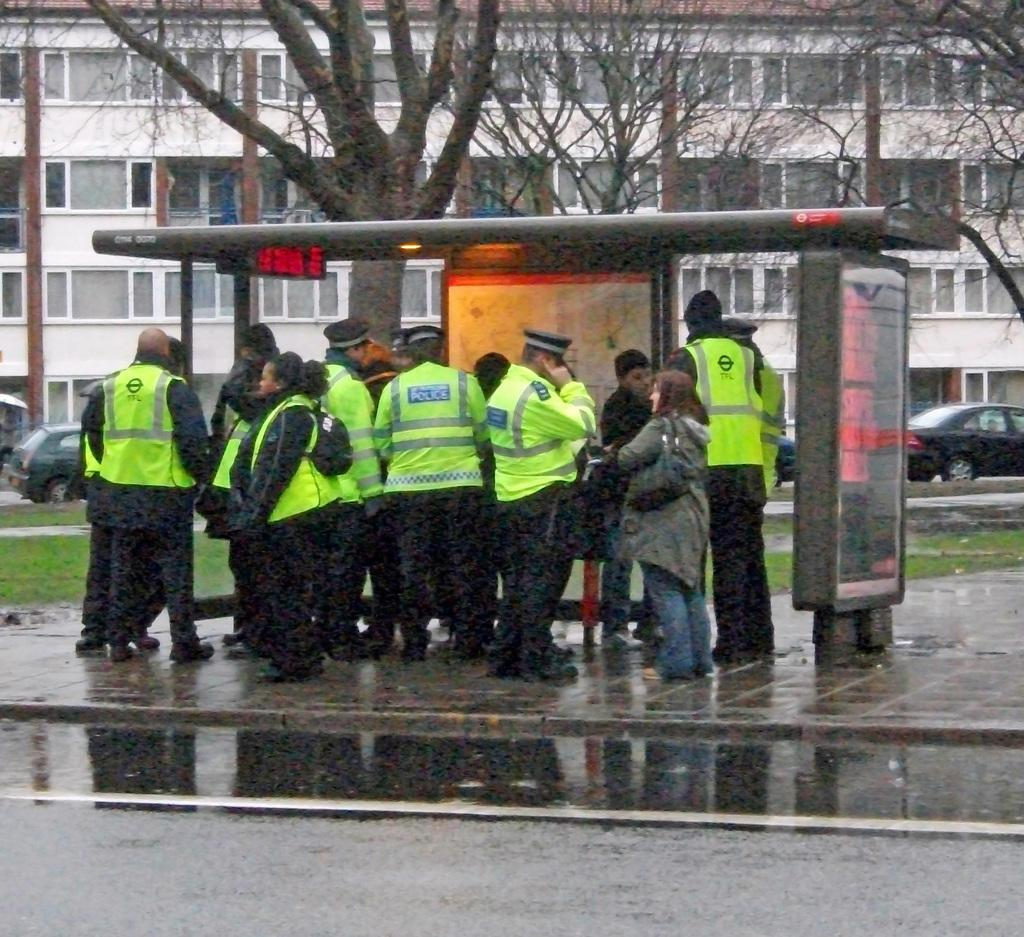What is happening in the image? There are persons standing in the image. What can be seen in the distance behind the persons? There are vehicles, trees, and a building in the background of the image. What type of cable is being used to measure the distance between the persons in the image? There is no cable or measuring activity present in the image. 